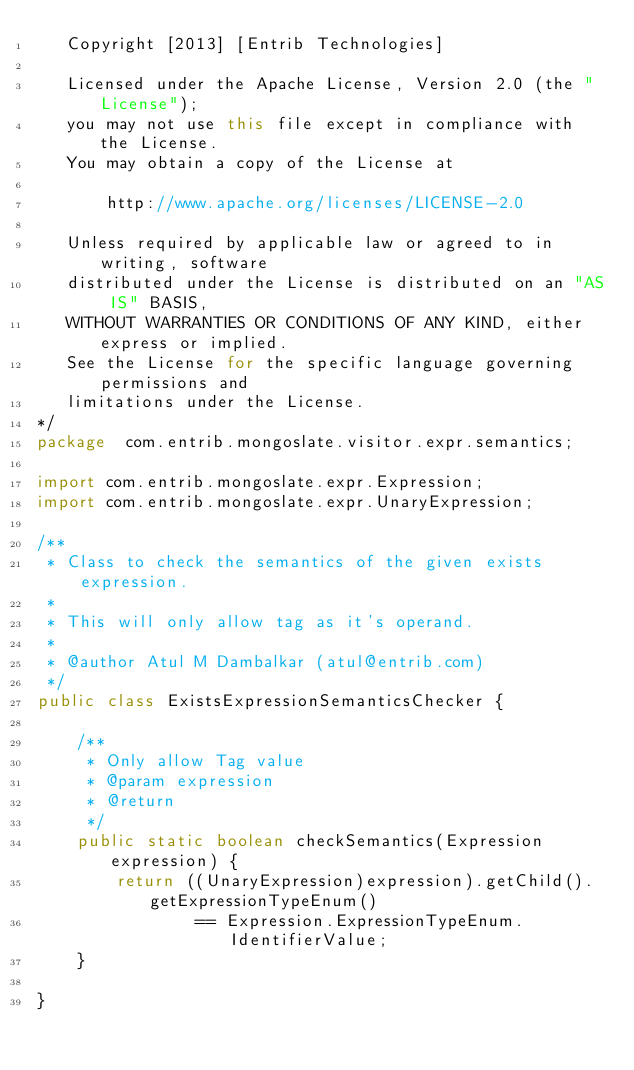Convert code to text. <code><loc_0><loc_0><loc_500><loc_500><_Java_>   Copyright [2013] [Entrib Technologies]

   Licensed under the Apache License, Version 2.0 (the "License");
   you may not use this file except in compliance with the License.
   You may obtain a copy of the License at

       http://www.apache.org/licenses/LICENSE-2.0

   Unless required by applicable law or agreed to in writing, software
   distributed under the License is distributed on an "AS IS" BASIS,
   WITHOUT WARRANTIES OR CONDITIONS OF ANY KIND, either express or implied.
   See the License for the specific language governing permissions and
   limitations under the License.
*/
package  com.entrib.mongoslate.visitor.expr.semantics;

import com.entrib.mongoslate.expr.Expression;
import com.entrib.mongoslate.expr.UnaryExpression;

/**
 * Class to check the semantics of the given exists expression.
 *
 * This will only allow tag as it's operand.
 *
 * @author Atul M Dambalkar (atul@entrib.com)
 */
public class ExistsExpressionSemanticsChecker {

    /**
     * Only allow Tag value
     * @param expression
     * @return
     */
    public static boolean checkSemantics(Expression expression) {
        return ((UnaryExpression)expression).getChild().getExpressionTypeEnum()
                == Expression.ExpressionTypeEnum.IdentifierValue;
    }

}
</code> 